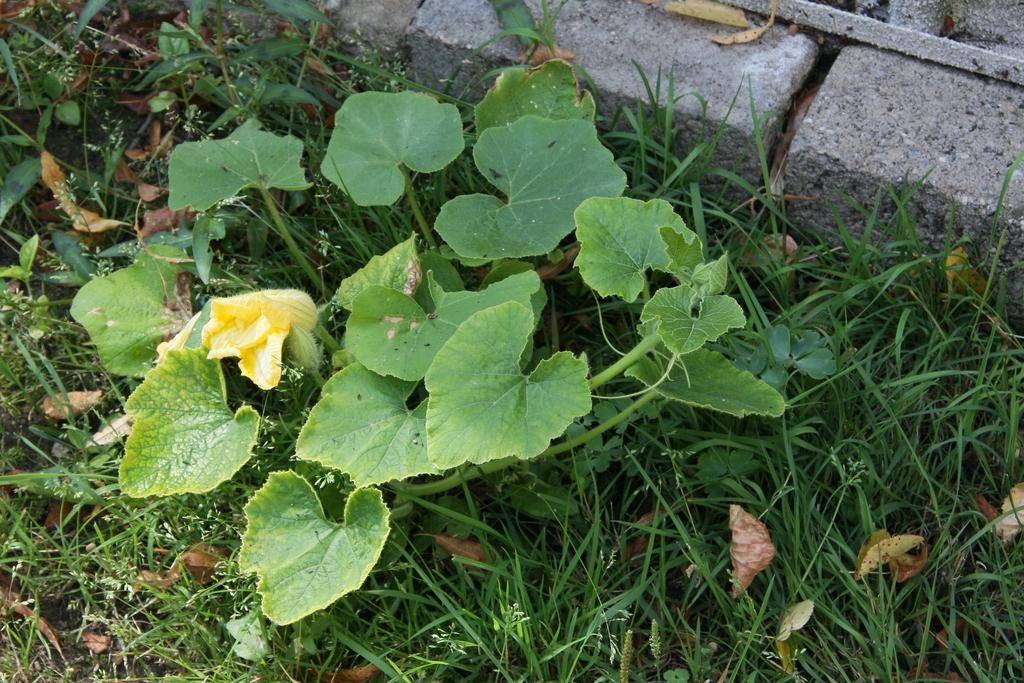What type of vegetation is present on the ground in the image? There are plants on the ground in the image. What type of ground cover can be seen in the image? There is grass visible in the image. What type of material is used for the stones in the image? There are cement stones in the image. What type of pollution can be seen in the image? There is no pollution visible in the image. Can you see a snake slithering through the grass in the image? There is no snake present in the image. 